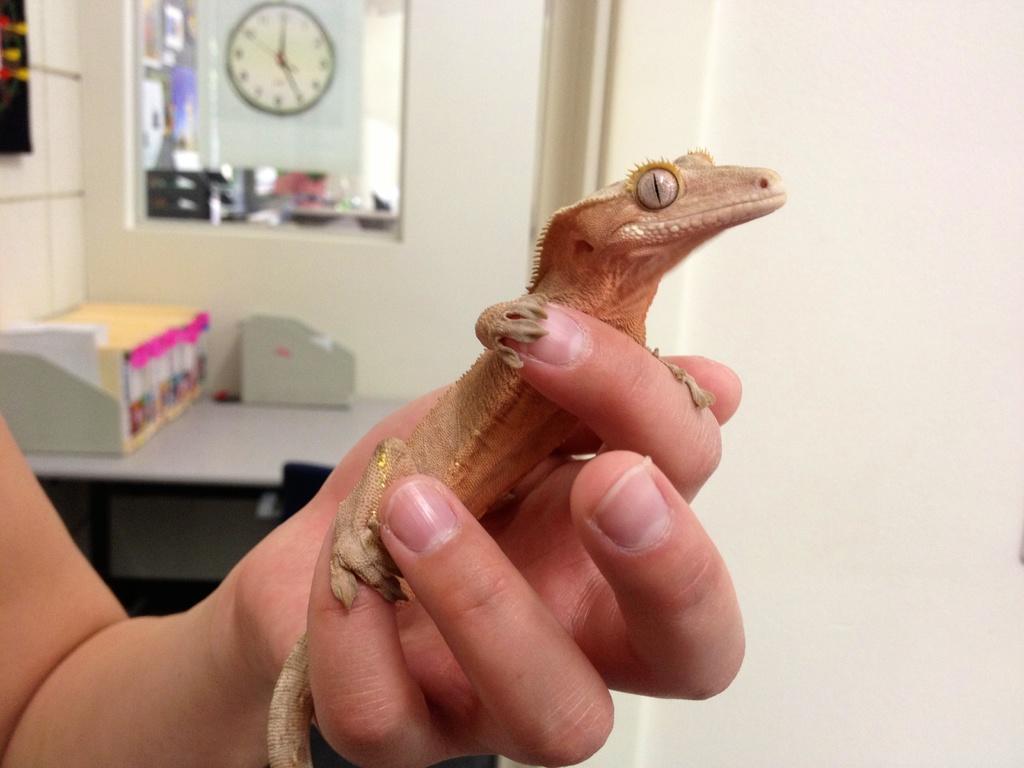Can you describe this image briefly? In this picture I can see there is a lizard on the person's hand and in the backdrop I can see there is a table here and there are some books placed on the table and there is a mirror and there is a clock on the wall. 